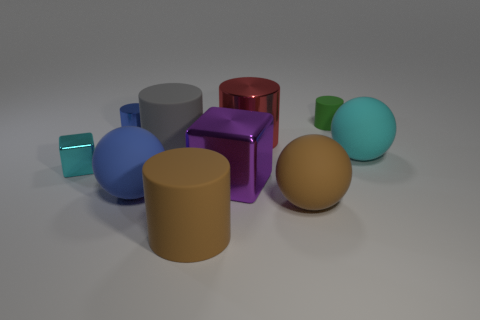Subtract all big shiny cylinders. How many cylinders are left? 4 Subtract all gray cylinders. How many cylinders are left? 4 Subtract all cubes. How many objects are left? 8 Subtract all purple cylinders. Subtract all gray balls. How many cylinders are left? 5 Subtract all cyan blocks. Subtract all green cylinders. How many objects are left? 8 Add 5 cyan shiny blocks. How many cyan shiny blocks are left? 6 Add 1 gray matte things. How many gray matte things exist? 2 Subtract 0 yellow cylinders. How many objects are left? 10 